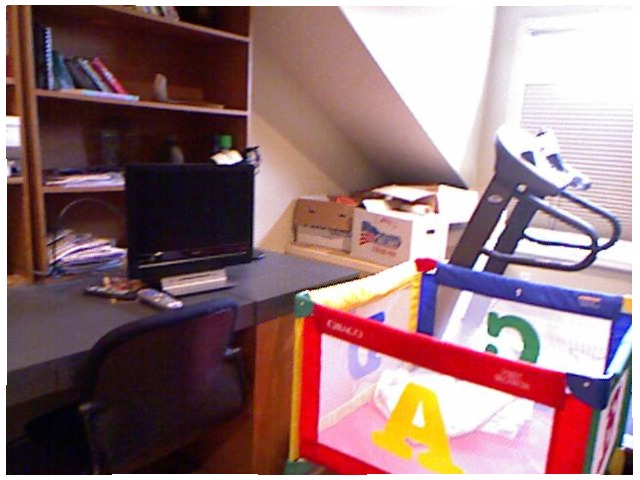<image>
Can you confirm if the letters is on the playpen? Yes. Looking at the image, I can see the letters is positioned on top of the playpen, with the playpen providing support. Is the book on the shelf? Yes. Looking at the image, I can see the book is positioned on top of the shelf, with the shelf providing support. Where is the crib in relation to the desk? Is it behind the desk? No. The crib is not behind the desk. From this viewpoint, the crib appears to be positioned elsewhere in the scene. 